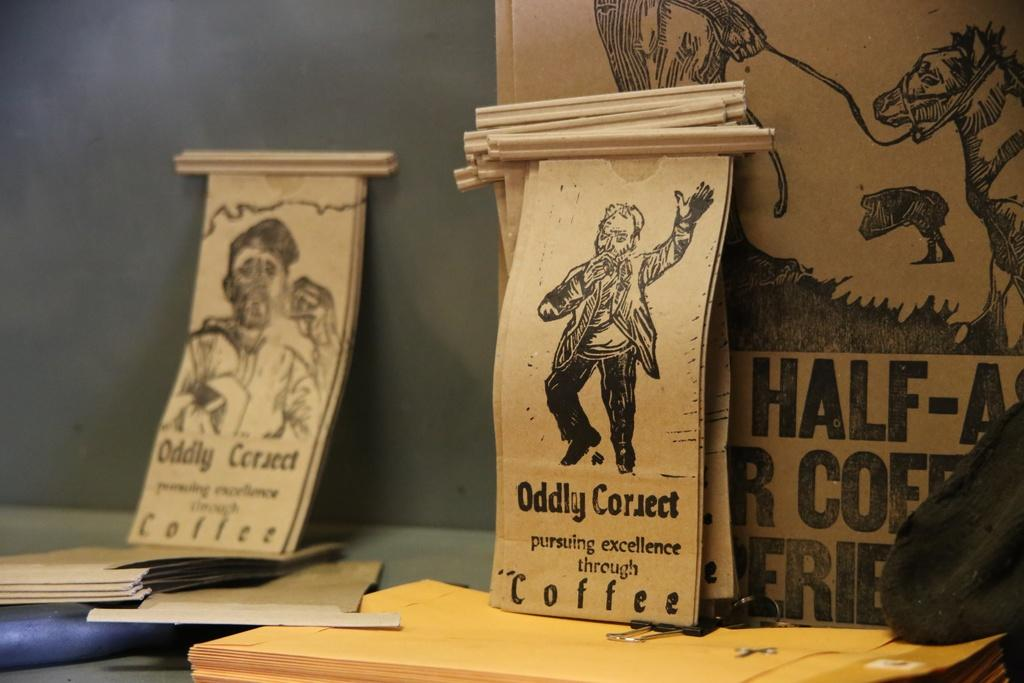Provide a one-sentence caption for the provided image. Tan colored scrolls sit atop a table and one reads "Oddly Correct" pursuing excellence through Coffee. 